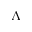<formula> <loc_0><loc_0><loc_500><loc_500>\Lambda</formula> 